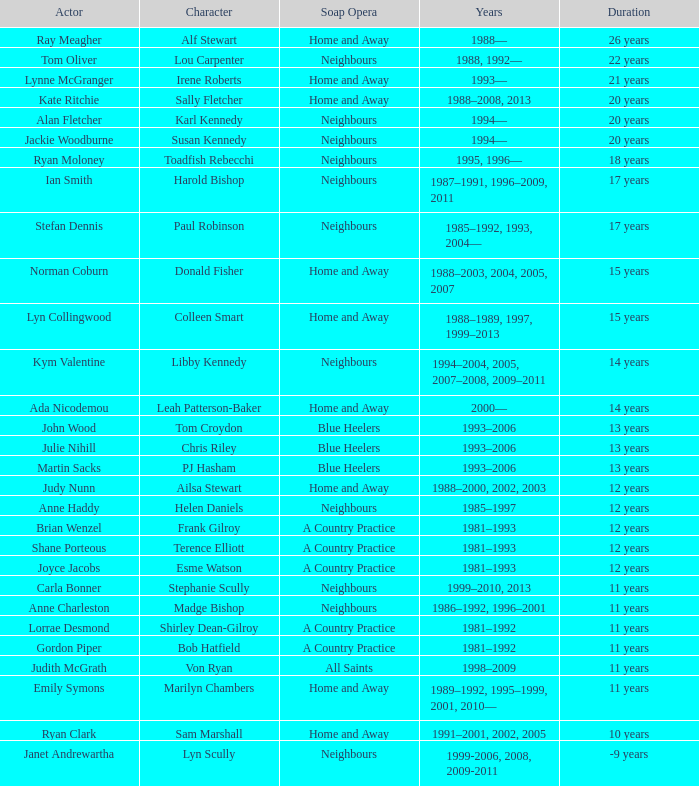What role was played by the same artist for 12 years on neighbours? Helen Daniels. 